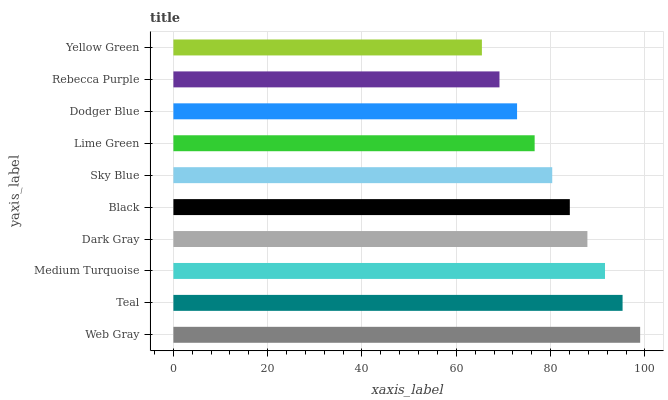Is Yellow Green the minimum?
Answer yes or no. Yes. Is Web Gray the maximum?
Answer yes or no. Yes. Is Teal the minimum?
Answer yes or no. No. Is Teal the maximum?
Answer yes or no. No. Is Web Gray greater than Teal?
Answer yes or no. Yes. Is Teal less than Web Gray?
Answer yes or no. Yes. Is Teal greater than Web Gray?
Answer yes or no. No. Is Web Gray less than Teal?
Answer yes or no. No. Is Black the high median?
Answer yes or no. Yes. Is Sky Blue the low median?
Answer yes or no. Yes. Is Yellow Green the high median?
Answer yes or no. No. Is Yellow Green the low median?
Answer yes or no. No. 